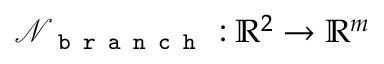<formula> <loc_0><loc_0><loc_500><loc_500>\mathcal { N } _ { b r a n c h } \colon \mathbb { R } ^ { 2 } \rightarrow \mathbb { R } ^ { m }</formula> 